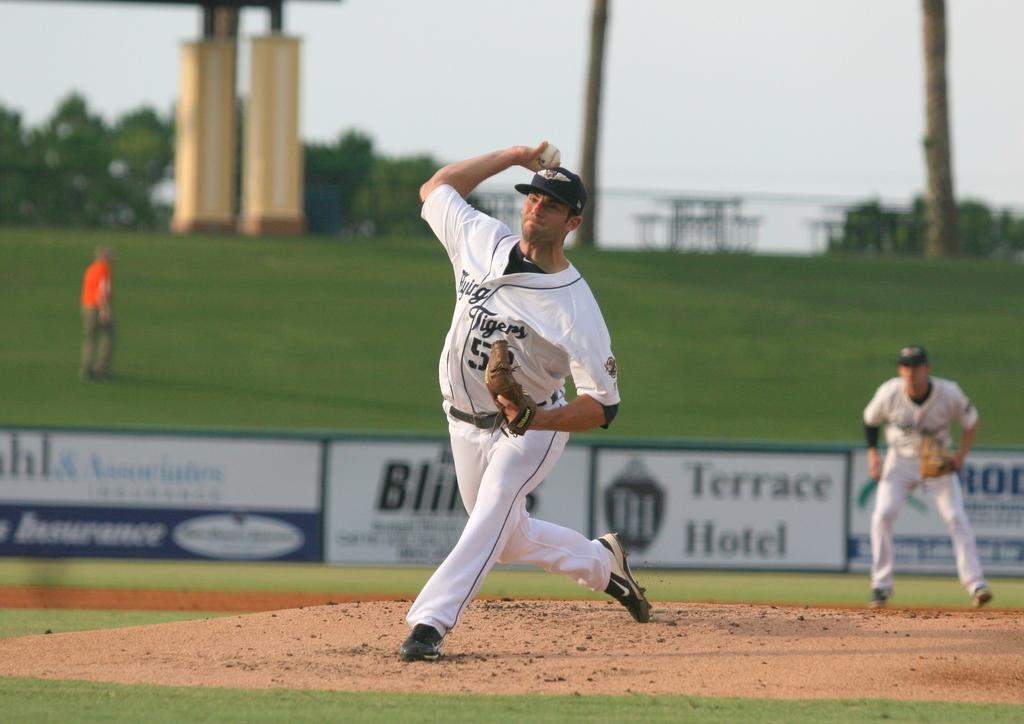<image>
Describe the image concisely. a jersey that has the name Tigers on it 